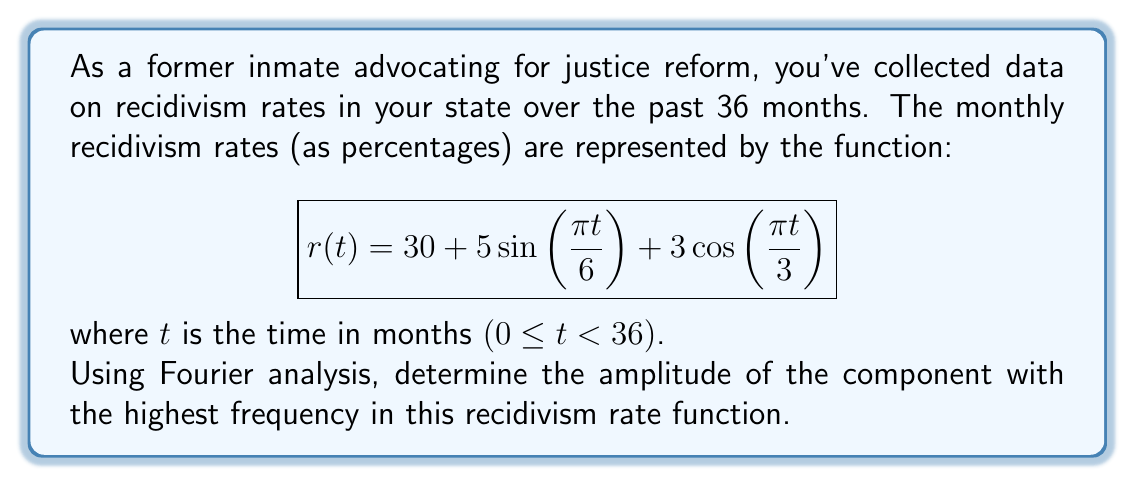What is the answer to this math problem? To solve this problem, we need to analyze the given function using Fourier analysis:

1) The given function is already in the form of a Fourier series:
   $$r(t) = 30 + 5\sin(\frac{\pi t}{6}) + 3\cos(\frac{\pi t}{3})$$

2) We can identify three components:
   - Constant term: 30
   - First sinusoidal term: $5\sin(\frac{\pi t}{6})$
   - Second sinusoidal term: $3\cos(\frac{\pi t}{3})$

3) The frequencies of these components are:
   - Constant term: 0 (no oscillation)
   - First sinusoidal term: $\frac{\pi}{6}$
   - Second sinusoidal term: $\frac{\pi}{3}$

4) The highest frequency is $\frac{\pi}{3}$, which corresponds to the cosine term.

5) The amplitude of a cosine term $A\cos(\omega t)$ is simply the coefficient $A$.

6) In this case, the amplitude of the highest frequency component is 3.

Therefore, the amplitude of the component with the highest frequency in the recidivism rate function is 3.
Answer: 3 